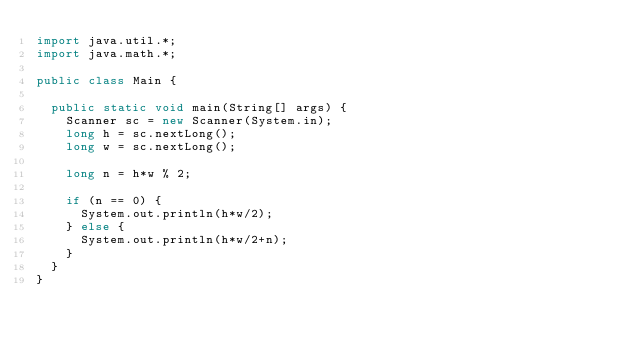<code> <loc_0><loc_0><loc_500><loc_500><_Java_>import java.util.*;
import java.math.*;

public class Main {

  public static void main(String[] args) {
    Scanner sc = new Scanner(System.in);
    long h = sc.nextLong();
    long w = sc.nextLong();

    long n = h*w % 2;

    if (n == 0) {
      System.out.println(h*w/2);
    } else {
      System.out.println(h*w/2+n);
    }
  }
}
</code> 